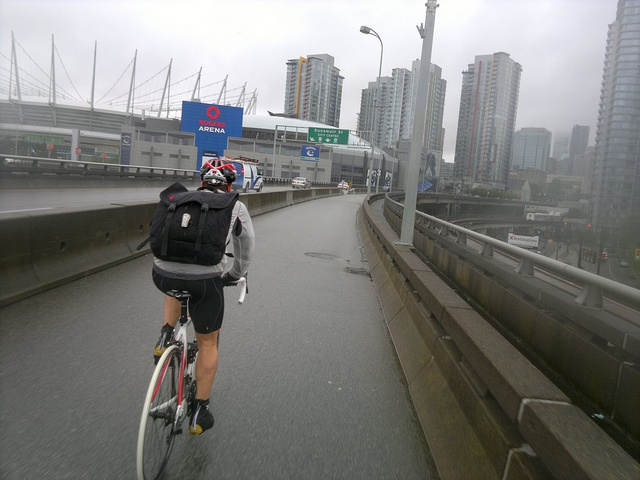Describe the objects in this image and their specific colors. I can see people in lightgray, black, gray, and darkgray tones, backpack in lightgray, black, gray, and darkgray tones, bicycle in lightgray, gray, black, and darkgray tones, bicycle in lightgray, gray, darkgray, and beige tones, and car in lightgray, gray, and darkgray tones in this image. 